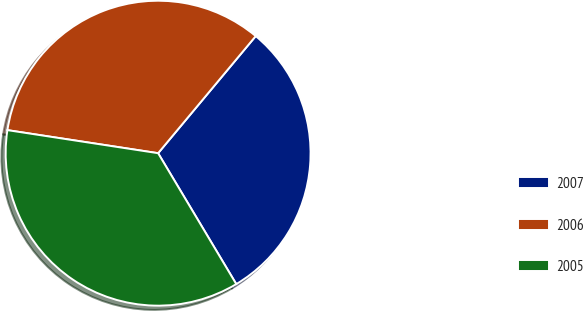<chart> <loc_0><loc_0><loc_500><loc_500><pie_chart><fcel>2007<fcel>2006<fcel>2005<nl><fcel>30.37%<fcel>33.64%<fcel>35.98%<nl></chart> 